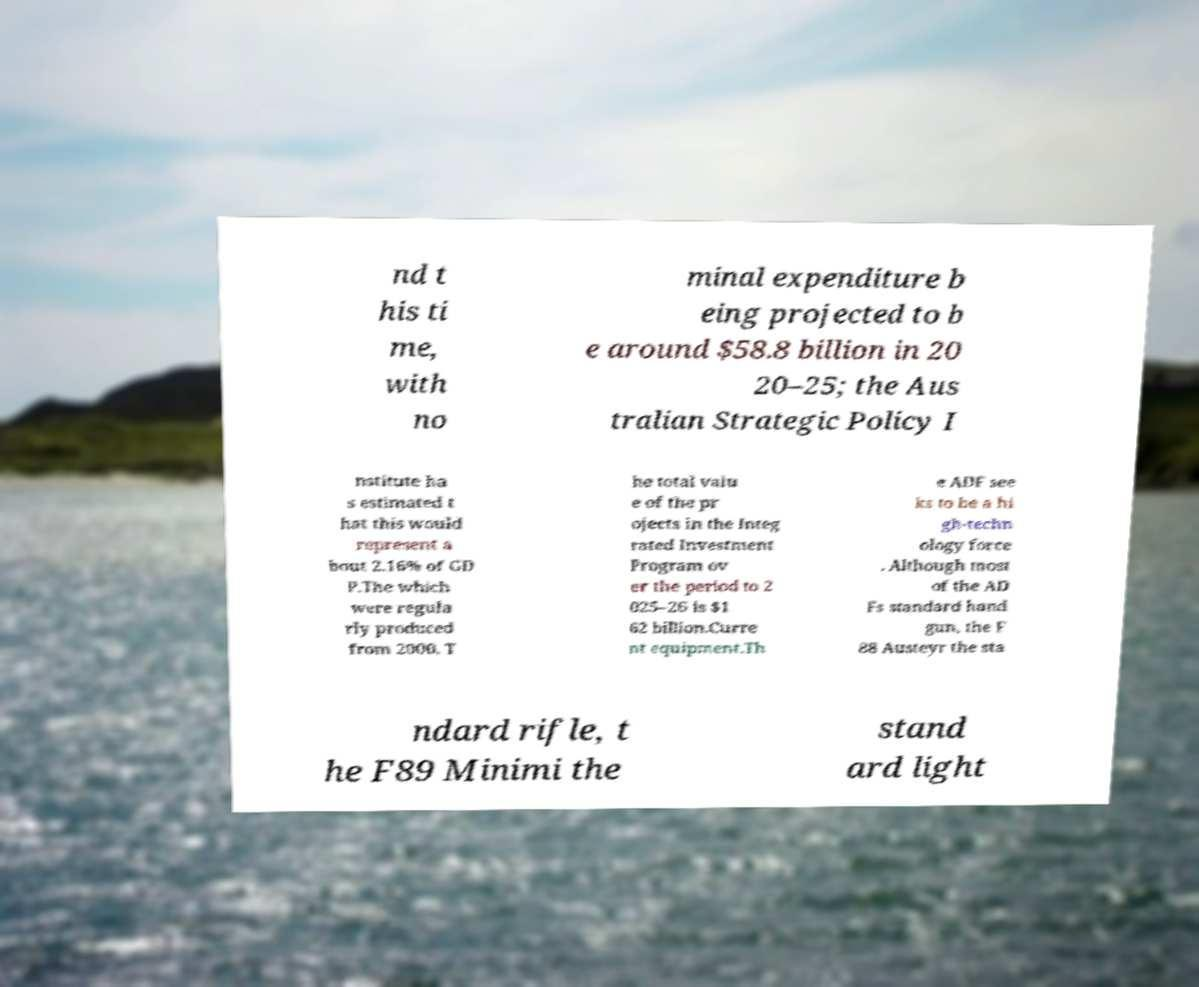I need the written content from this picture converted into text. Can you do that? nd t his ti me, with no minal expenditure b eing projected to b e around $58.8 billion in 20 20–25; the Aus tralian Strategic Policy I nstitute ha s estimated t hat this would represent a bout 2.16% of GD P.The which were regula rly produced from 2000. T he total valu e of the pr ojects in the Integ rated Investment Program ov er the period to 2 025–26 is $1 62 billion.Curre nt equipment.Th e ADF see ks to be a hi gh-techn ology force . Although most of the AD Fs standard hand gun, the F 88 Austeyr the sta ndard rifle, t he F89 Minimi the stand ard light 